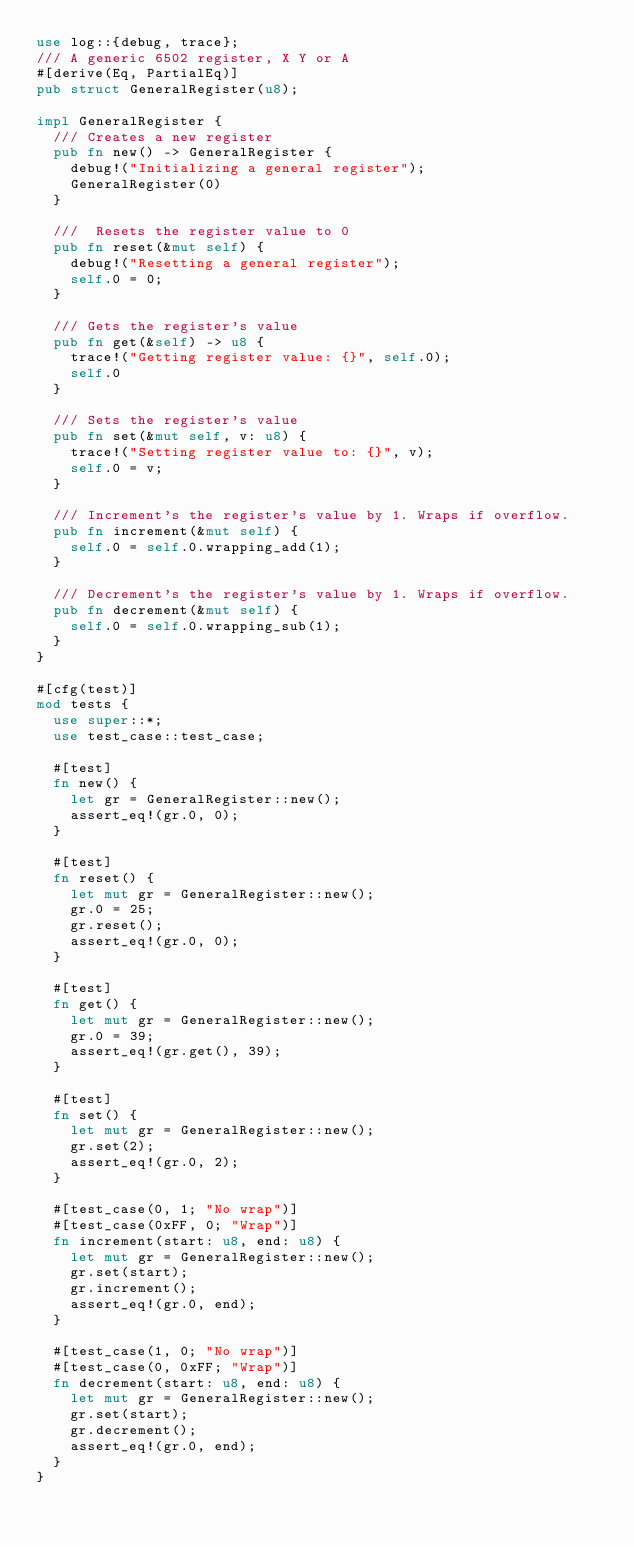<code> <loc_0><loc_0><loc_500><loc_500><_Rust_>use log::{debug, trace};
/// A generic 6502 register, X Y or A
#[derive(Eq, PartialEq)]
pub struct GeneralRegister(u8);

impl GeneralRegister {
  /// Creates a new register
  pub fn new() -> GeneralRegister {
    debug!("Initializing a general register");
    GeneralRegister(0)
  }

  ///  Resets the register value to 0
  pub fn reset(&mut self) {
    debug!("Resetting a general register");
    self.0 = 0;
  }

  /// Gets the register's value
  pub fn get(&self) -> u8 {
    trace!("Getting register value: {}", self.0);
    self.0
  }

  /// Sets the register's value
  pub fn set(&mut self, v: u8) {
    trace!("Setting register value to: {}", v);
    self.0 = v;
  }

  /// Increment's the register's value by 1. Wraps if overflow.
  pub fn increment(&mut self) {
    self.0 = self.0.wrapping_add(1);
  }

  /// Decrement's the register's value by 1. Wraps if overflow.
  pub fn decrement(&mut self) {
    self.0 = self.0.wrapping_sub(1);
  }
}

#[cfg(test)]
mod tests {
  use super::*;
  use test_case::test_case;

  #[test]
  fn new() {
    let gr = GeneralRegister::new();
    assert_eq!(gr.0, 0);
  }

  #[test]
  fn reset() {
    let mut gr = GeneralRegister::new();
    gr.0 = 25;
    gr.reset();
    assert_eq!(gr.0, 0);
  }

  #[test]
  fn get() {
    let mut gr = GeneralRegister::new();
    gr.0 = 39;
    assert_eq!(gr.get(), 39);
  }

  #[test]
  fn set() {
    let mut gr = GeneralRegister::new();
    gr.set(2);
    assert_eq!(gr.0, 2);
  }

  #[test_case(0, 1; "No wrap")]
  #[test_case(0xFF, 0; "Wrap")]
  fn increment(start: u8, end: u8) {
    let mut gr = GeneralRegister::new();
    gr.set(start);
    gr.increment();
    assert_eq!(gr.0, end);
  }

  #[test_case(1, 0; "No wrap")]
  #[test_case(0, 0xFF; "Wrap")]
  fn decrement(start: u8, end: u8) {
    let mut gr = GeneralRegister::new();
    gr.set(start);
    gr.decrement();
    assert_eq!(gr.0, end);
  }
}
</code> 